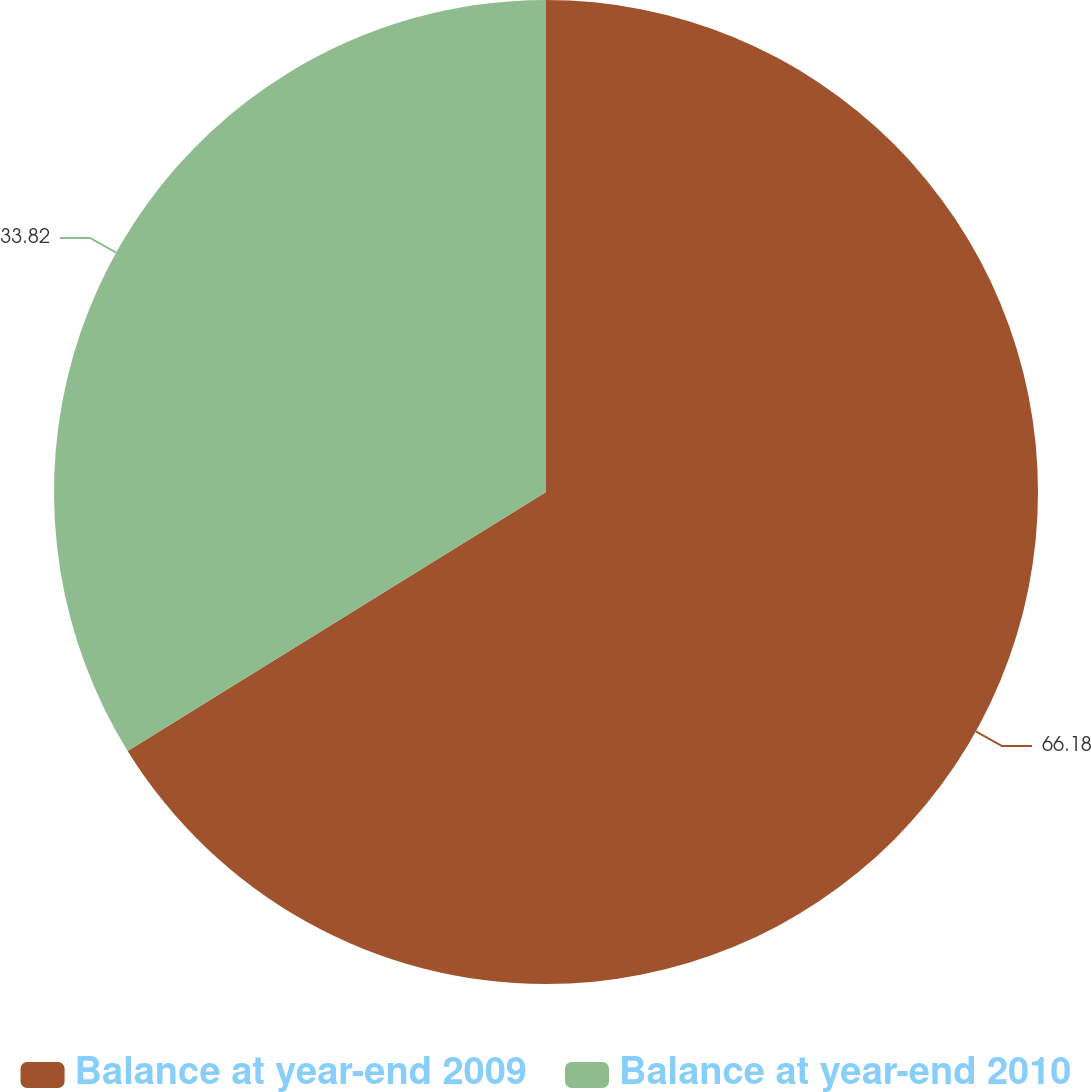<chart> <loc_0><loc_0><loc_500><loc_500><pie_chart><fcel>Balance at year-end 2009<fcel>Balance at year-end 2010<nl><fcel>66.18%<fcel>33.82%<nl></chart> 